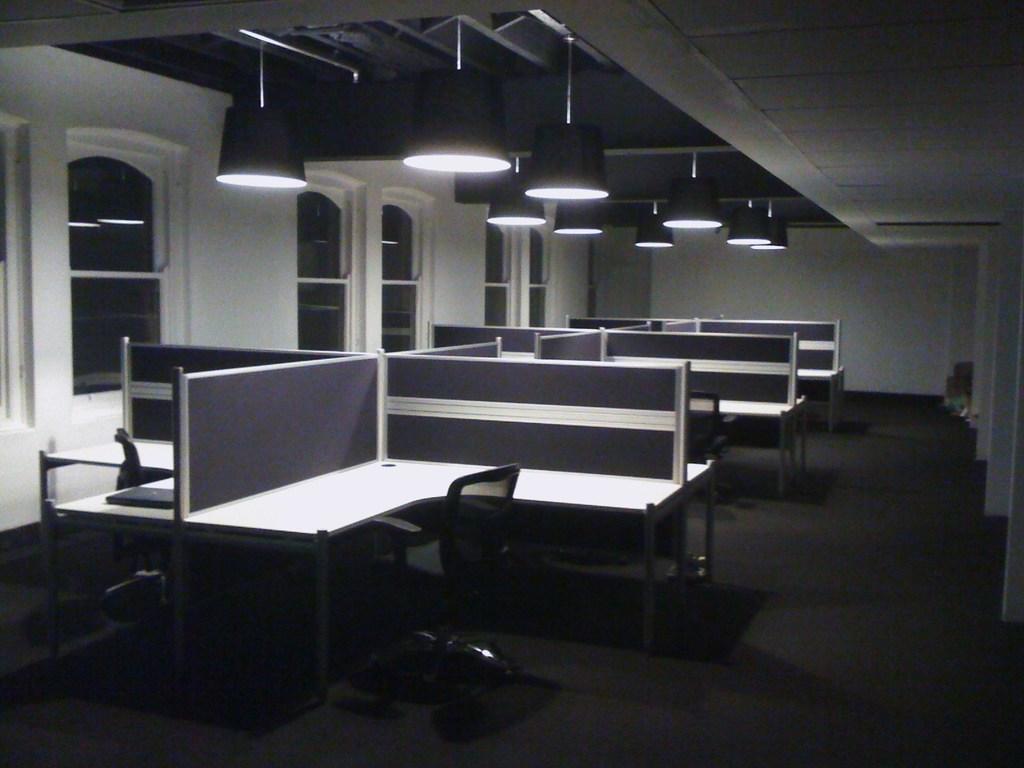Can you describe this image briefly? In this image I can see few desks and the chairs. I can see an object on the desk. There are lights at the top. In the background I can see the windows to the wall. 